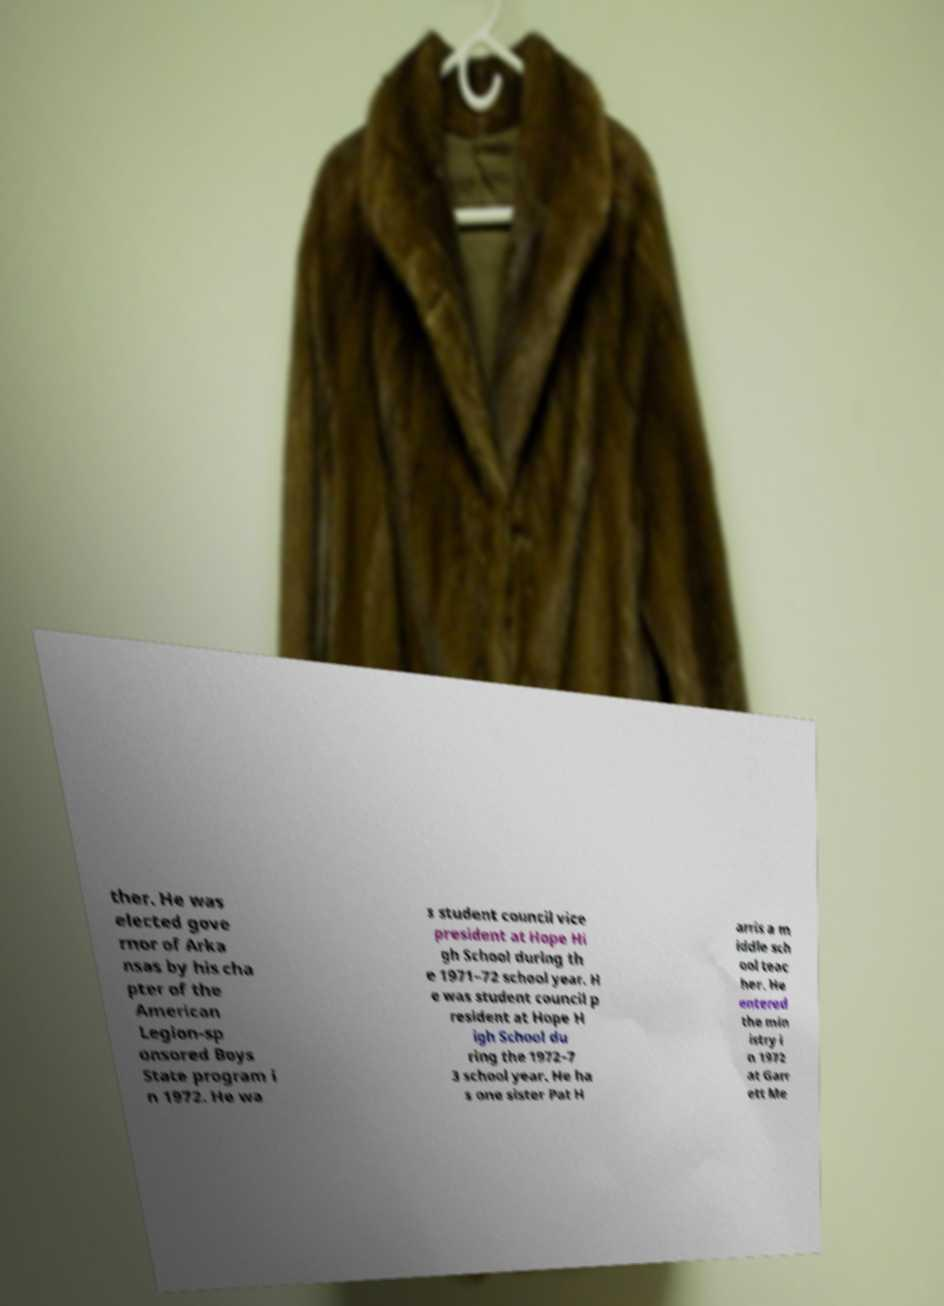For documentation purposes, I need the text within this image transcribed. Could you provide that? ther. He was elected gove rnor of Arka nsas by his cha pter of the American Legion-sp onsored Boys State program i n 1972. He wa s student council vice president at Hope Hi gh School during th e 1971–72 school year. H e was student council p resident at Hope H igh School du ring the 1972–7 3 school year. He ha s one sister Pat H arris a m iddle sch ool teac her. He entered the min istry i n 1972 at Garr ett Me 